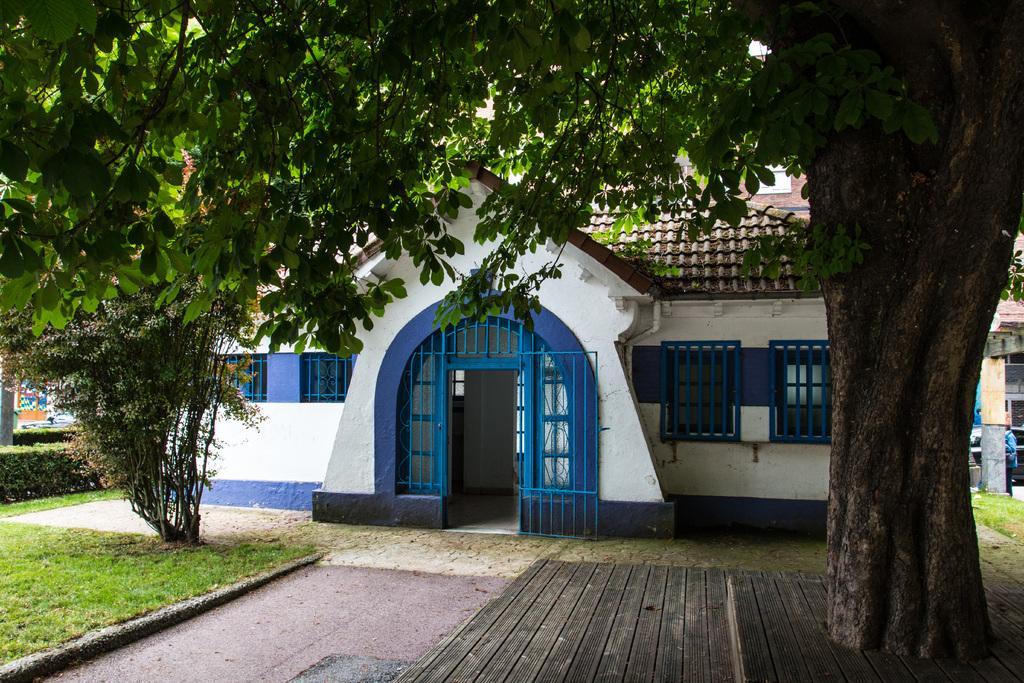Please provide a concise description of this image. This looks like a house with a door and windows. Here is the roof. I can see the trees with branches and leaves. Here is the grass. This looks like a wooden platform. Here is the pathway. These are the bushes. On the right side of the image, I can see a pillar and a person standing. 